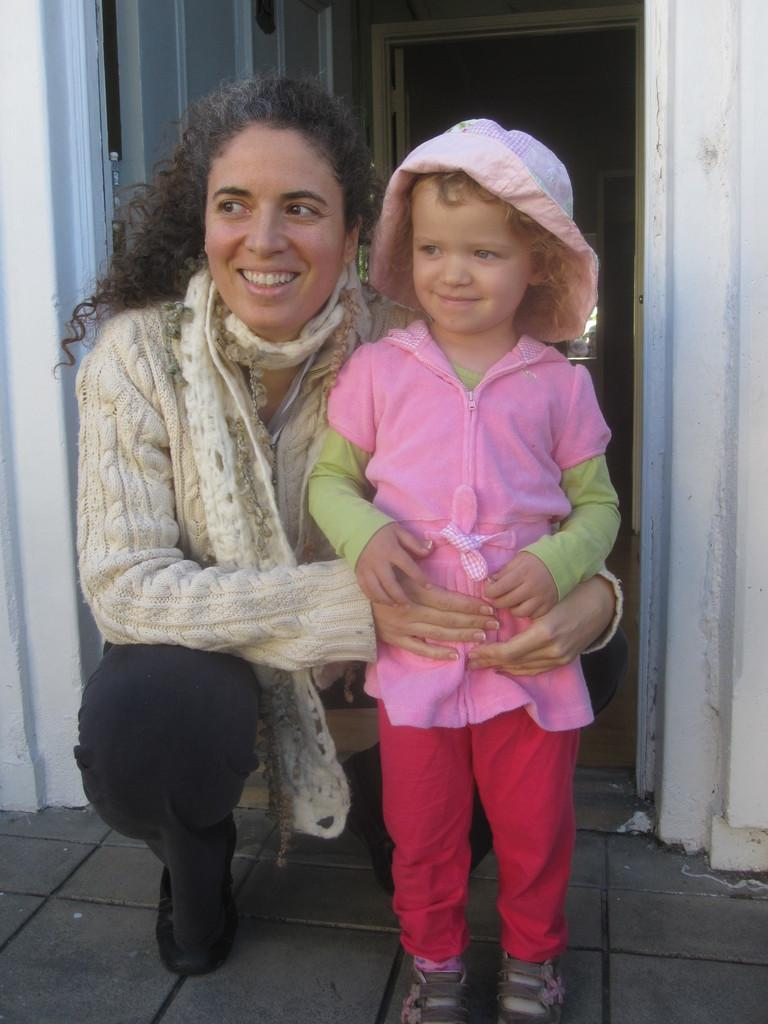Who is the main subject in the image? There is a woman in the image. What is the woman doing in the image? The woman is holding a girl and is in a squat position. What can be seen in the background of the image? There is a door in the background of the image. How many cows are visible in the image? There are no cows present in the image. Is there a fight happening between the woman and the girl in the image? There is no fight depicted in the image; the woman is holding the girl in a squat position. 